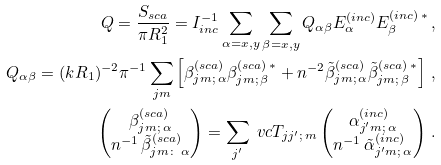Convert formula to latex. <formula><loc_0><loc_0><loc_500><loc_500>Q = \frac { S _ { s c a } } { \pi R _ { 1 } ^ { 2 } } = I _ { i n c } ^ { - 1 } \sum _ { \alpha = x , y } \sum _ { \beta = x , y } Q _ { \alpha \beta } E _ { \alpha } ^ { ( i n c ) } E _ { \beta } ^ { ( i n c ) \, * } \, , \\ Q _ { \alpha \beta } = ( k R _ { 1 } ) ^ { - 2 } \pi ^ { - 1 } \sum _ { j m } \left [ \beta _ { j m ; \, \alpha } ^ { ( s c a ) } \beta _ { j m ; \, \beta } ^ { ( s c a ) \, * } + n ^ { - 2 } \tilde { \beta } _ { j m ; \, \alpha } ^ { ( s c a ) } \tilde { \beta } _ { j m ; \, \beta } ^ { ( s c a ) \, * } \right ] \, , \\ \begin{pmatrix} \beta _ { j m ; \, \alpha } ^ { ( s c a ) } \\ n ^ { - 1 } \, \tilde { \beta } _ { j m \colon \, \alpha } ^ { ( s c a ) } \end{pmatrix} = \sum _ { j ^ { \prime } } \ v c { T } _ { j j ^ { \prime } ; \, m } \begin{pmatrix} \alpha _ { j ^ { \prime } m ; \, \alpha } ^ { ( i n c ) } \\ n ^ { - 1 } \, \tilde { \alpha } _ { j ^ { \prime } m ; \, \alpha } ^ { ( i n c ) } \end{pmatrix} \, .</formula> 